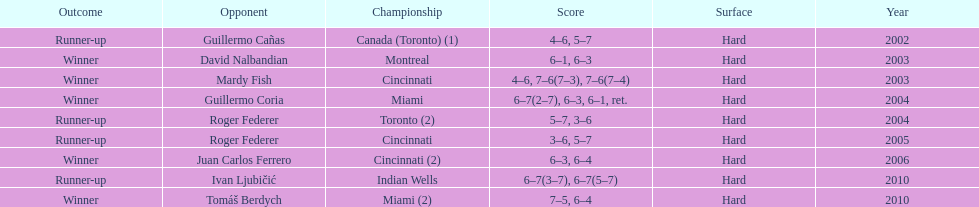What was the highest number of consecutive wins? 3. 